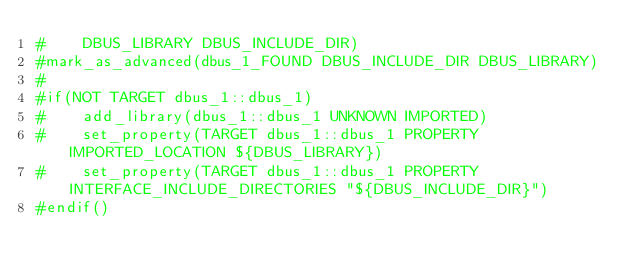<code> <loc_0><loc_0><loc_500><loc_500><_CMake_>#    DBUS_LIBRARY DBUS_INCLUDE_DIR)
#mark_as_advanced(dbus_1_FOUND DBUS_INCLUDE_DIR DBUS_LIBRARY)
#
#if(NOT TARGET dbus_1::dbus_1)
#    add_library(dbus_1::dbus_1 UNKNOWN IMPORTED)
#    set_property(TARGET dbus_1::dbus_1 PROPERTY IMPORTED_LOCATION ${DBUS_LIBRARY})
#    set_property(TARGET dbus_1::dbus_1 PROPERTY INTERFACE_INCLUDE_DIRECTORIES "${DBUS_INCLUDE_DIR}")
#endif()

</code> 